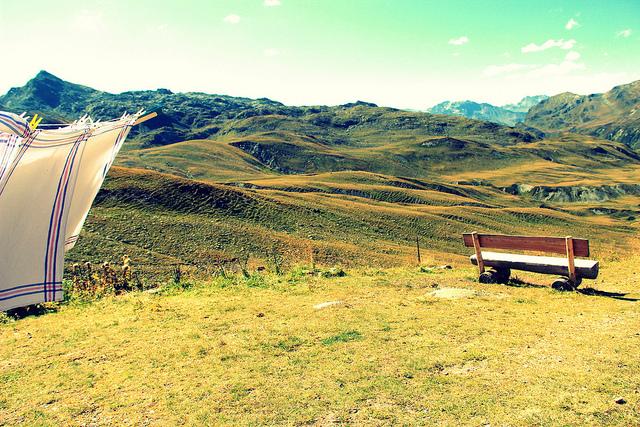What is the bench facing?
Answer briefly. Mountains. What is the bench made of?
Write a very short answer. Wood. Would the terrain pictured be easy to travel through on a bicycle?
Short answer required. No. 